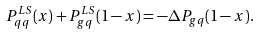<formula> <loc_0><loc_0><loc_500><loc_500>P _ { q q } ^ { L S } ( x ) + P _ { g q } ^ { L S } ( 1 - x ) = - \Delta P _ { g q } ( 1 - x ) .</formula> 